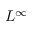<formula> <loc_0><loc_0><loc_500><loc_500>L ^ { \infty }</formula> 